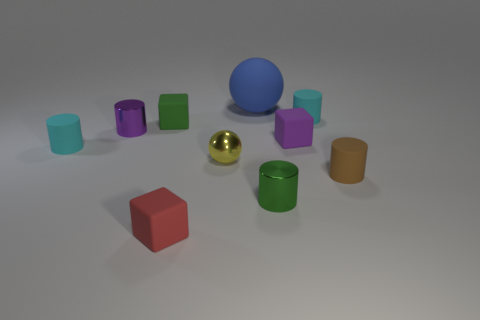Subtract all yellow balls. How many balls are left? 1 Subtract all balls. How many objects are left? 8 Subtract all small cyan cylinders. How many cylinders are left? 3 Subtract 1 cylinders. How many cylinders are left? 4 Subtract all brown cylinders. How many gray cubes are left? 0 Add 5 green shiny cylinders. How many green shiny cylinders exist? 6 Subtract 0 brown spheres. How many objects are left? 10 Subtract all blue spheres. Subtract all gray cubes. How many spheres are left? 1 Subtract all tiny yellow rubber objects. Subtract all small red matte blocks. How many objects are left? 9 Add 4 big blue matte spheres. How many big blue matte spheres are left? 5 